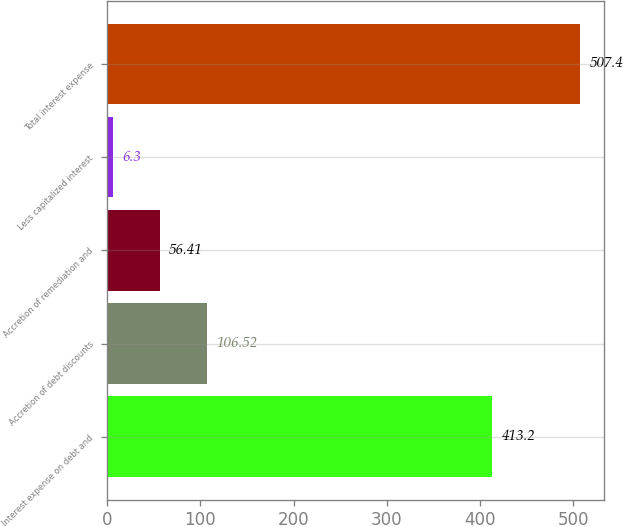Convert chart to OTSL. <chart><loc_0><loc_0><loc_500><loc_500><bar_chart><fcel>Interest expense on debt and<fcel>Accretion of debt discounts<fcel>Accretion of remediation and<fcel>Less capitalized interest<fcel>Total interest expense<nl><fcel>413.2<fcel>106.52<fcel>56.41<fcel>6.3<fcel>507.4<nl></chart> 